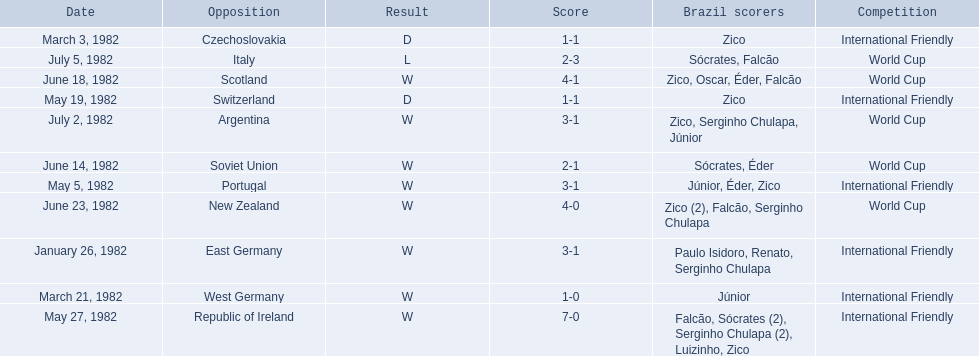How many goals did brazil score against the soviet union? 2-1. How many goals did brazil score against portugal? 3-1. Did brazil score more goals against portugal or the soviet union? Portugal. 